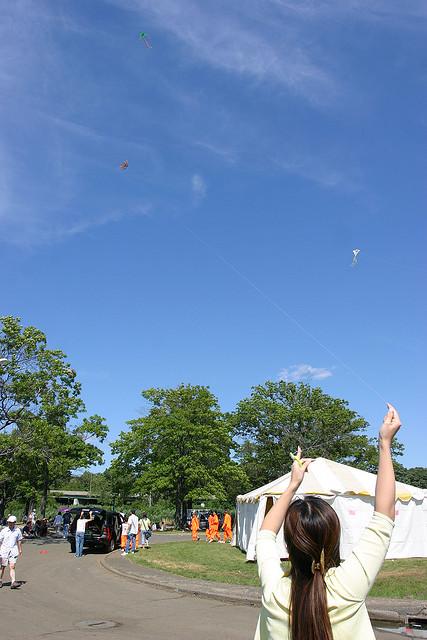What is the woman doing with her hands?
Write a very short answer. Flying kite. What does the woman's shirt and the pop up tent in back have in common?
Concise answer only. White. What color is the tent?
Keep it brief. White. 